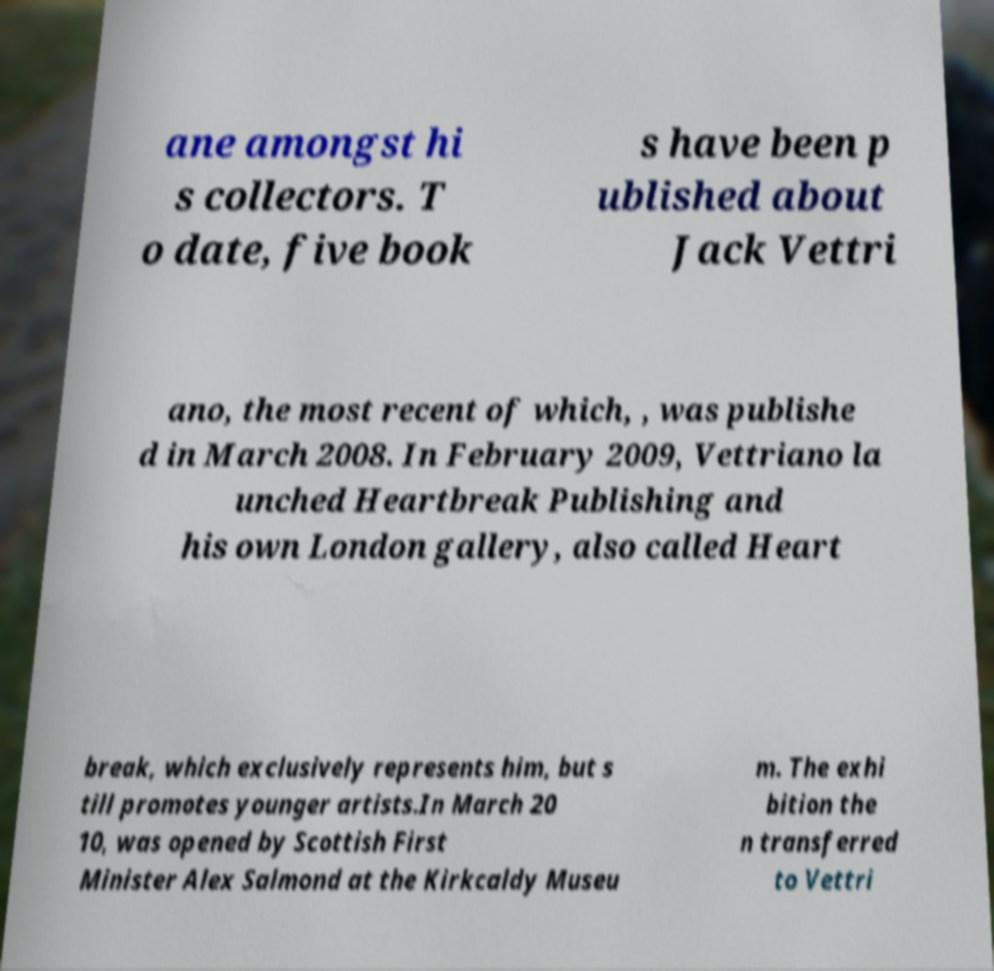There's text embedded in this image that I need extracted. Can you transcribe it verbatim? ane amongst hi s collectors. T o date, five book s have been p ublished about Jack Vettri ano, the most recent of which, , was publishe d in March 2008. In February 2009, Vettriano la unched Heartbreak Publishing and his own London gallery, also called Heart break, which exclusively represents him, but s till promotes younger artists.In March 20 10, was opened by Scottish First Minister Alex Salmond at the Kirkcaldy Museu m. The exhi bition the n transferred to Vettri 